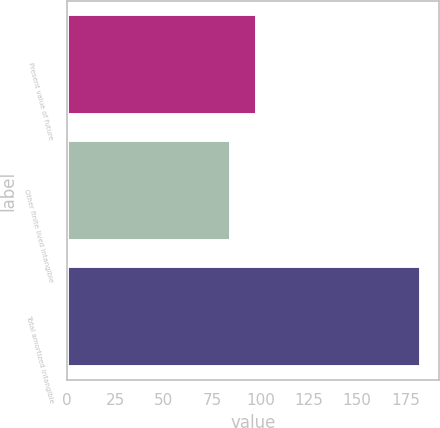Convert chart. <chart><loc_0><loc_0><loc_500><loc_500><bar_chart><fcel>Present value of future<fcel>Other finite lived intangible<fcel>Total amortized intangible<nl><fcel>98.4<fcel>84.7<fcel>183.1<nl></chart> 